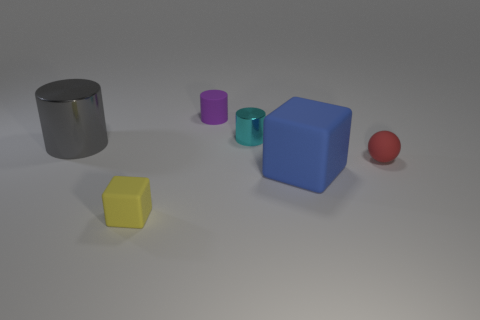Subtract all gray cylinders. How many cylinders are left? 2 Add 2 gray cylinders. How many objects exist? 8 Subtract 1 cylinders. How many cylinders are left? 2 Subtract all balls. How many objects are left? 5 Subtract all yellow cylinders. Subtract all purple blocks. How many cylinders are left? 3 Subtract 0 cyan balls. How many objects are left? 6 Subtract all cyan things. Subtract all tiny metal cylinders. How many objects are left? 4 Add 3 blue matte objects. How many blue matte objects are left? 4 Add 3 tiny rubber cylinders. How many tiny rubber cylinders exist? 4 